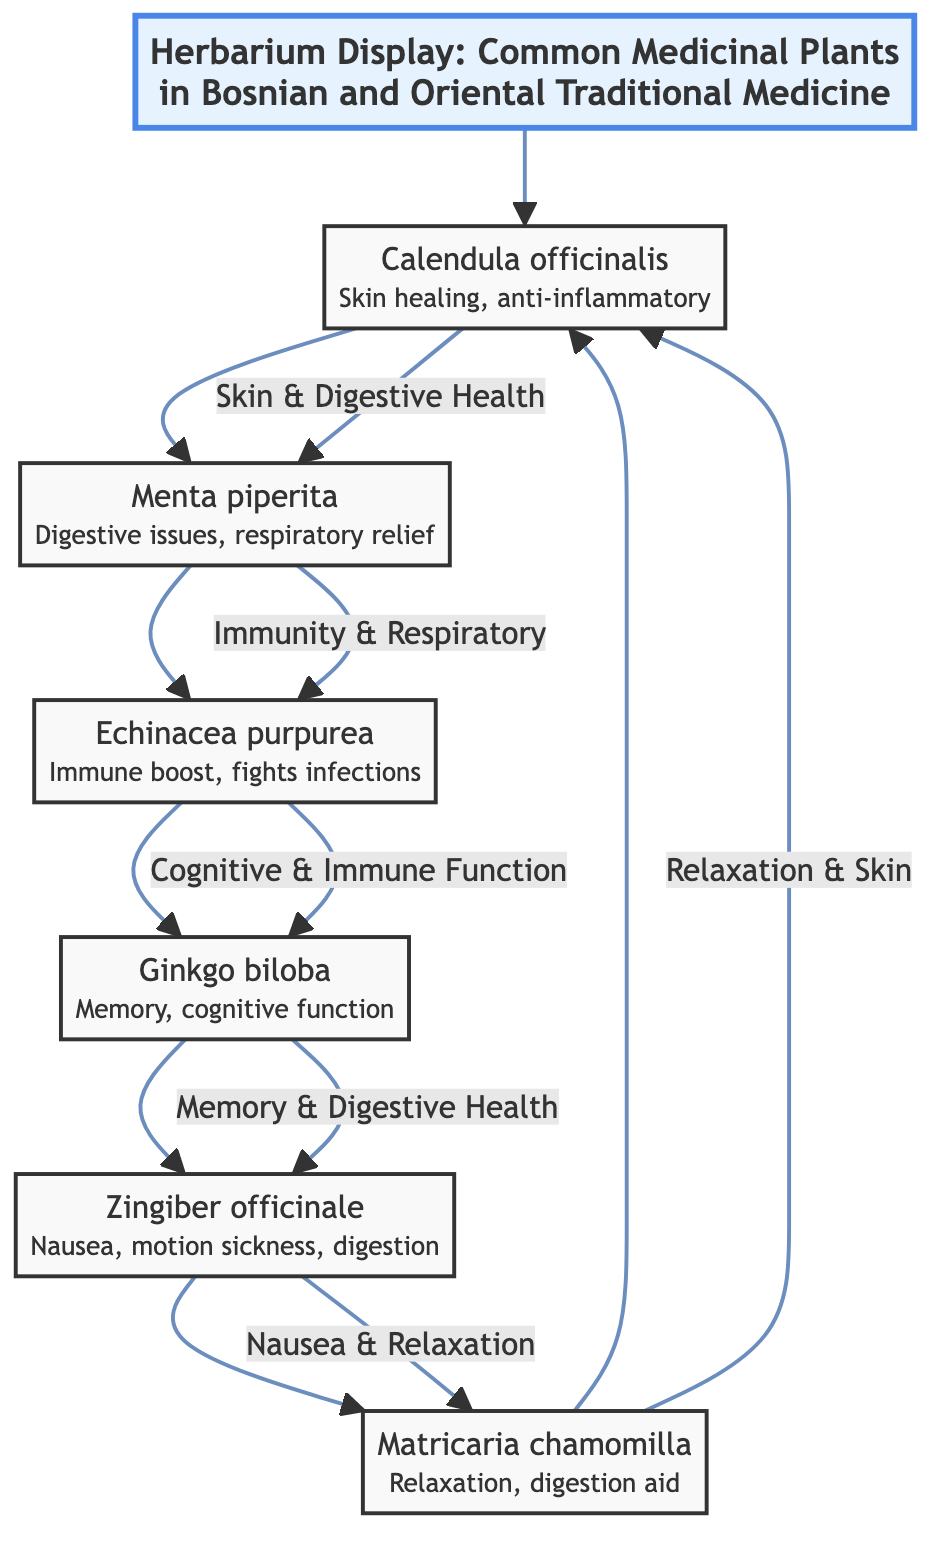What is the main title of the diagram? The diagram begins with a title node labeled "Herbarium Display: Common Medicinal Plants in Bosnian and Oriental Traditional Medicine."
Answer: Herbarium Display: Common Medicinal Plants in Bosnian and Oriental Traditional Medicine How many medicinal plants are listed in the diagram? The diagram contains a total of 6 medicinal plants, as represented by the nodes labeled 1 through 6.
Answer: 6 What is the function of Calendula officinalis? The diagram states that Calendula officinalis is associated with "Skin healing, anti-inflammatory."
Answer: Skin healing, anti-inflammatory Which two plants are connected through "Immunity & Respiratory"? The connection "Immunity & Respiratory" links the nodes for Menta piperita and Echinacea purpurea.
Answer: Menta piperita and Echinacea purpurea What connectively relates Zingiber officinale to Matricaria chamomilla? The relationship described as "Nausea & Relaxation" connects Zingiber officinale to Matricaria chamomilla in the diagram.
Answer: Nausea & Relaxation Which plant is connected to memory and cognitive function? The node describing Ginkgo biloba states its function as relating to "Memory, cognitive function," connecting it to the respective cognitive health aspect.
Answer: Ginkgo biloba What is the last plant mentioned before returning to the first in the flow? The last plant mentioned in the flow before returning to the first is Matricaria chamomilla.
Answer: Matricaria chamomilla Which plant serves a role in digestive issues according to the diagram? The diagram clearly indicates that Menta piperita is related to digestive issues, as listed in its function description.
Answer: Menta piperita What type of relationships do the edges between plants indicate? The edges in the diagram indicate health relationships and synergistic functions among the listed medicinal plants.
Answer: Health relationships and synergistic functions 